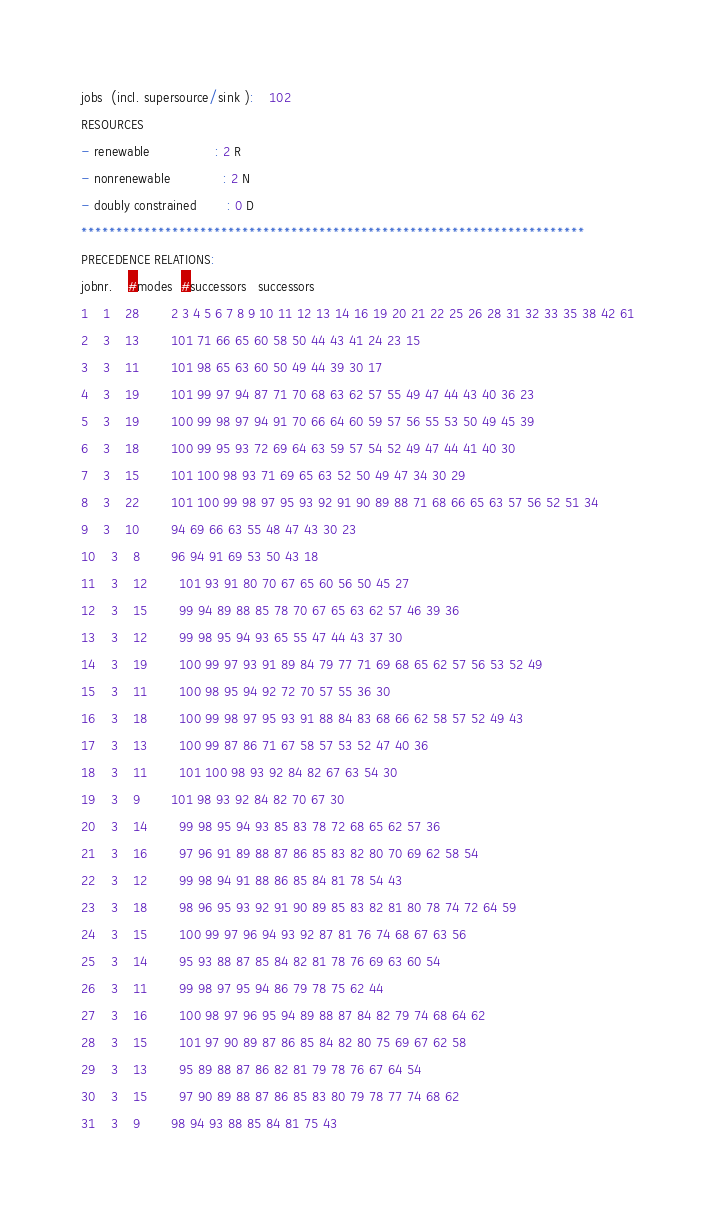<code> <loc_0><loc_0><loc_500><loc_500><_ObjectiveC_>jobs  (incl. supersource/sink ):	102
RESOURCES
- renewable                 : 2 R
- nonrenewable              : 2 N
- doubly constrained        : 0 D
************************************************************************
PRECEDENCE RELATIONS:
jobnr.    #modes  #successors   successors
1	1	28		2 3 4 5 6 7 8 9 10 11 12 13 14 16 19 20 21 22 25 26 28 31 32 33 35 38 42 61 
2	3	13		101 71 66 65 60 58 50 44 43 41 24 23 15 
3	3	11		101 98 65 63 60 50 49 44 39 30 17 
4	3	19		101 99 97 94 87 71 70 68 63 62 57 55 49 47 44 43 40 36 23 
5	3	19		100 99 98 97 94 91 70 66 64 60 59 57 56 55 53 50 49 45 39 
6	3	18		100 99 95 93 72 69 64 63 59 57 54 52 49 47 44 41 40 30 
7	3	15		101 100 98 93 71 69 65 63 52 50 49 47 34 30 29 
8	3	22		101 100 99 98 97 95 93 92 91 90 89 88 71 68 66 65 63 57 56 52 51 34 
9	3	10		94 69 66 63 55 48 47 43 30 23 
10	3	8		96 94 91 69 53 50 43 18 
11	3	12		101 93 91 80 70 67 65 60 56 50 45 27 
12	3	15		99 94 89 88 85 78 70 67 65 63 62 57 46 39 36 
13	3	12		99 98 95 94 93 65 55 47 44 43 37 30 
14	3	19		100 99 97 93 91 89 84 79 77 71 69 68 65 62 57 56 53 52 49 
15	3	11		100 98 95 94 92 72 70 57 55 36 30 
16	3	18		100 99 98 97 95 93 91 88 84 83 68 66 62 58 57 52 49 43 
17	3	13		100 99 87 86 71 67 58 57 53 52 47 40 36 
18	3	11		101 100 98 93 92 84 82 67 63 54 30 
19	3	9		101 98 93 92 84 82 70 67 30 
20	3	14		99 98 95 94 93 85 83 78 72 68 65 62 57 36 
21	3	16		97 96 91 89 88 87 86 85 83 82 80 70 69 62 58 54 
22	3	12		99 98 94 91 88 86 85 84 81 78 54 43 
23	3	18		98 96 95 93 92 91 90 89 85 83 82 81 80 78 74 72 64 59 
24	3	15		100 99 97 96 94 93 92 87 81 76 74 68 67 63 56 
25	3	14		95 93 88 87 85 84 82 81 78 76 69 63 60 54 
26	3	11		99 98 97 95 94 86 79 78 75 62 44 
27	3	16		100 98 97 96 95 94 89 88 87 84 82 79 74 68 64 62 
28	3	15		101 97 90 89 87 86 85 84 82 80 75 69 67 62 58 
29	3	13		95 89 88 87 86 82 81 79 78 76 67 64 54 
30	3	15		97 90 89 88 87 86 85 83 80 79 78 77 74 68 62 
31	3	9		98 94 93 88 85 84 81 75 43 </code> 